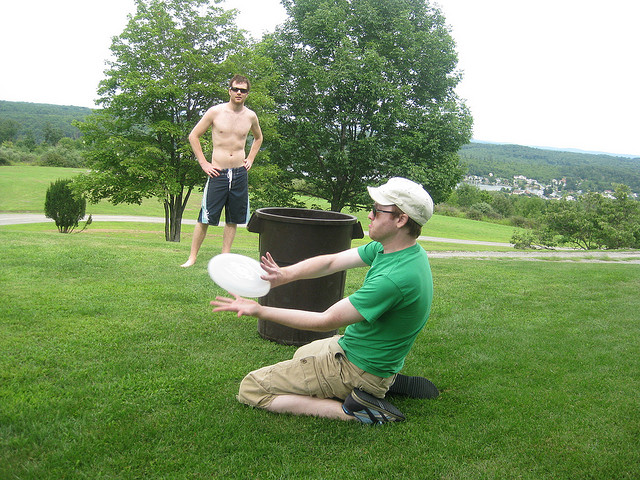Describe the setting where these two men are playing. The setting is a lush, expansive outdoor area likely within a park. It features ample green grass and scattered trees, offering a serene backdrop. In the distance, residential buildings can be seen, suggesting this park is near a suburban area. 